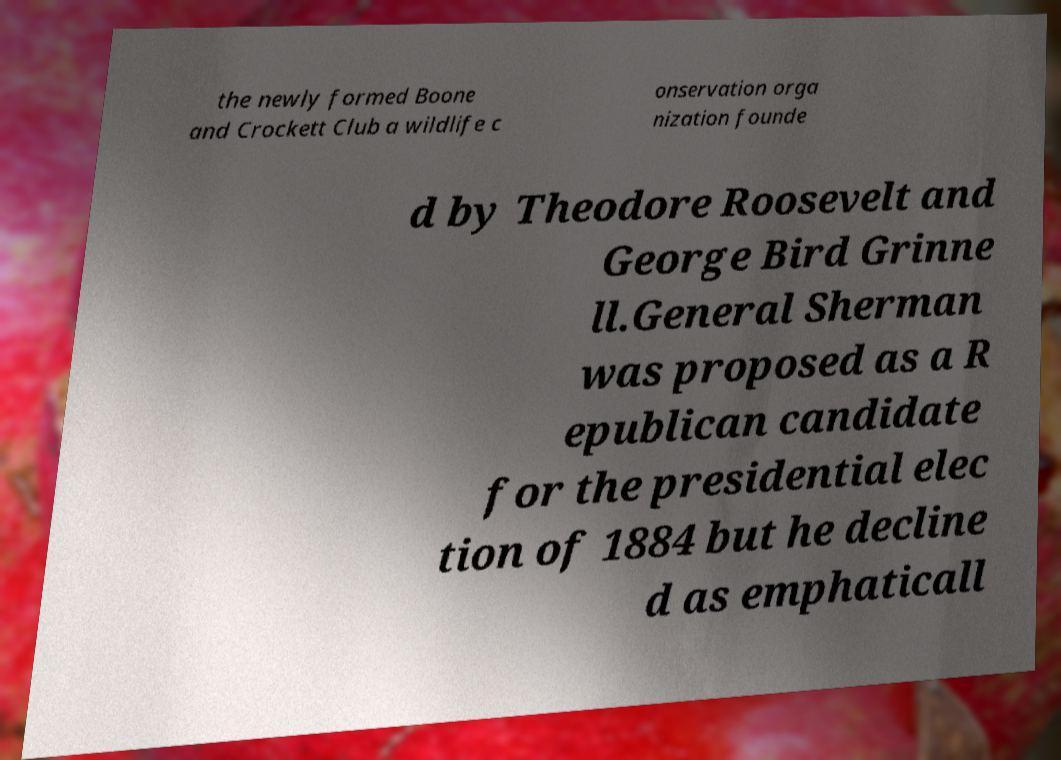I need the written content from this picture converted into text. Can you do that? the newly formed Boone and Crockett Club a wildlife c onservation orga nization founde d by Theodore Roosevelt and George Bird Grinne ll.General Sherman was proposed as a R epublican candidate for the presidential elec tion of 1884 but he decline d as emphaticall 